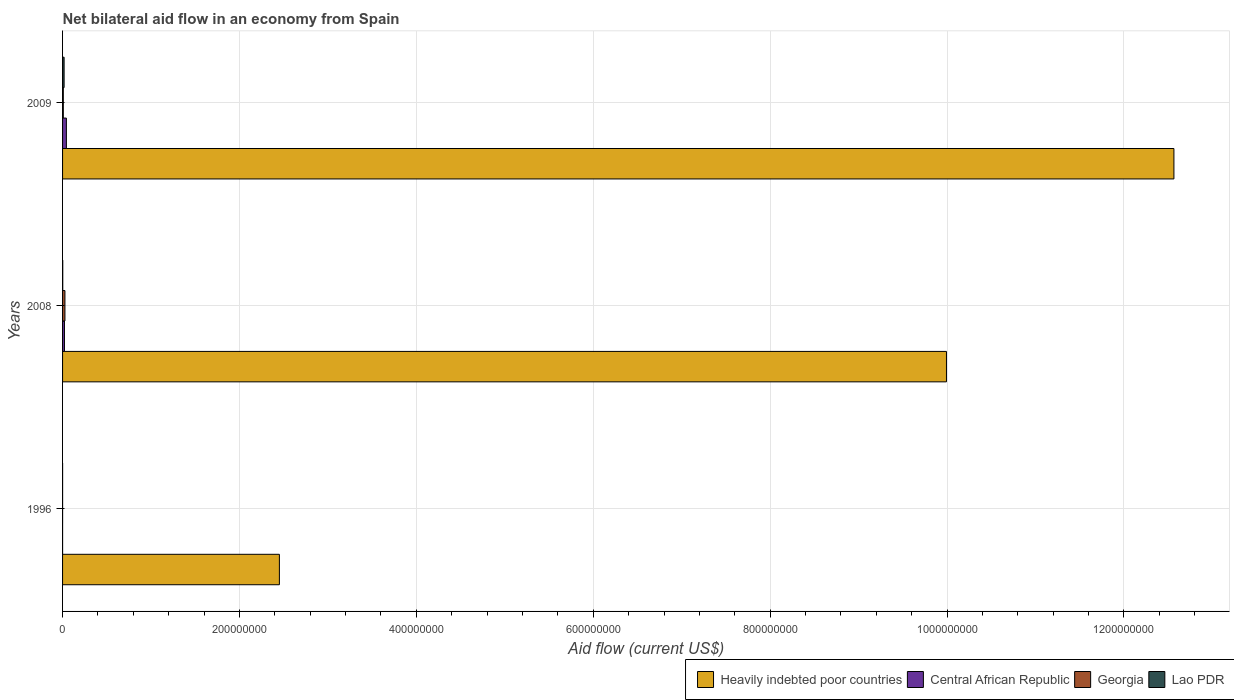Are the number of bars on each tick of the Y-axis equal?
Your answer should be very brief. Yes. How many bars are there on the 3rd tick from the bottom?
Ensure brevity in your answer.  4. What is the net bilateral aid flow in Central African Republic in 2008?
Make the answer very short. 2.15e+06. Across all years, what is the maximum net bilateral aid flow in Georgia?
Give a very brief answer. 2.69e+06. Across all years, what is the minimum net bilateral aid flow in Georgia?
Make the answer very short. 3.00e+04. In which year was the net bilateral aid flow in Central African Republic maximum?
Offer a terse response. 2009. What is the total net bilateral aid flow in Heavily indebted poor countries in the graph?
Make the answer very short. 2.50e+09. What is the difference between the net bilateral aid flow in Lao PDR in 2008 and that in 2009?
Provide a short and direct response. -1.54e+06. What is the difference between the net bilateral aid flow in Central African Republic in 2009 and the net bilateral aid flow in Lao PDR in 2008?
Your answer should be very brief. 4.13e+06. What is the average net bilateral aid flow in Heavily indebted poor countries per year?
Your answer should be compact. 8.34e+08. In the year 2009, what is the difference between the net bilateral aid flow in Central African Republic and net bilateral aid flow in Georgia?
Make the answer very short. 3.48e+06. What is the ratio of the net bilateral aid flow in Central African Republic in 2008 to that in 2009?
Your answer should be compact. 0.5. Is the net bilateral aid flow in Heavily indebted poor countries in 1996 less than that in 2008?
Your answer should be very brief. Yes. What is the difference between the highest and the second highest net bilateral aid flow in Lao PDR?
Offer a terse response. 1.54e+06. What is the difference between the highest and the lowest net bilateral aid flow in Lao PDR?
Your answer should be compact. 1.71e+06. In how many years, is the net bilateral aid flow in Lao PDR greater than the average net bilateral aid flow in Lao PDR taken over all years?
Your answer should be compact. 1. Is the sum of the net bilateral aid flow in Heavily indebted poor countries in 2008 and 2009 greater than the maximum net bilateral aid flow in Georgia across all years?
Provide a short and direct response. Yes. Is it the case that in every year, the sum of the net bilateral aid flow in Central African Republic and net bilateral aid flow in Georgia is greater than the sum of net bilateral aid flow in Heavily indebted poor countries and net bilateral aid flow in Lao PDR?
Your answer should be very brief. No. What does the 1st bar from the top in 2008 represents?
Provide a succinct answer. Lao PDR. What does the 4th bar from the bottom in 1996 represents?
Keep it short and to the point. Lao PDR. Is it the case that in every year, the sum of the net bilateral aid flow in Lao PDR and net bilateral aid flow in Central African Republic is greater than the net bilateral aid flow in Heavily indebted poor countries?
Provide a succinct answer. No. How many years are there in the graph?
Provide a succinct answer. 3. Does the graph contain any zero values?
Keep it short and to the point. No. Where does the legend appear in the graph?
Make the answer very short. Bottom right. What is the title of the graph?
Provide a succinct answer. Net bilateral aid flow in an economy from Spain. Does "Indonesia" appear as one of the legend labels in the graph?
Offer a terse response. No. What is the label or title of the X-axis?
Your answer should be compact. Aid flow (current US$). What is the Aid flow (current US$) of Heavily indebted poor countries in 1996?
Make the answer very short. 2.45e+08. What is the Aid flow (current US$) in Central African Republic in 1996?
Provide a short and direct response. 2.00e+04. What is the Aid flow (current US$) in Georgia in 1996?
Keep it short and to the point. 3.00e+04. What is the Aid flow (current US$) of Lao PDR in 1996?
Offer a terse response. 3.00e+04. What is the Aid flow (current US$) in Heavily indebted poor countries in 2008?
Offer a terse response. 9.99e+08. What is the Aid flow (current US$) in Central African Republic in 2008?
Offer a very short reply. 2.15e+06. What is the Aid flow (current US$) of Georgia in 2008?
Offer a terse response. 2.69e+06. What is the Aid flow (current US$) of Heavily indebted poor countries in 2009?
Provide a short and direct response. 1.26e+09. What is the Aid flow (current US$) in Central African Republic in 2009?
Give a very brief answer. 4.33e+06. What is the Aid flow (current US$) of Georgia in 2009?
Provide a succinct answer. 8.50e+05. What is the Aid flow (current US$) of Lao PDR in 2009?
Keep it short and to the point. 1.74e+06. Across all years, what is the maximum Aid flow (current US$) of Heavily indebted poor countries?
Offer a very short reply. 1.26e+09. Across all years, what is the maximum Aid flow (current US$) of Central African Republic?
Your answer should be compact. 4.33e+06. Across all years, what is the maximum Aid flow (current US$) of Georgia?
Give a very brief answer. 2.69e+06. Across all years, what is the maximum Aid flow (current US$) in Lao PDR?
Offer a terse response. 1.74e+06. Across all years, what is the minimum Aid flow (current US$) in Heavily indebted poor countries?
Ensure brevity in your answer.  2.45e+08. Across all years, what is the minimum Aid flow (current US$) in Central African Republic?
Your answer should be compact. 2.00e+04. Across all years, what is the minimum Aid flow (current US$) of Georgia?
Provide a succinct answer. 3.00e+04. Across all years, what is the minimum Aid flow (current US$) in Lao PDR?
Give a very brief answer. 3.00e+04. What is the total Aid flow (current US$) in Heavily indebted poor countries in the graph?
Give a very brief answer. 2.50e+09. What is the total Aid flow (current US$) of Central African Republic in the graph?
Your answer should be very brief. 6.50e+06. What is the total Aid flow (current US$) in Georgia in the graph?
Provide a succinct answer. 3.57e+06. What is the total Aid flow (current US$) of Lao PDR in the graph?
Your response must be concise. 1.97e+06. What is the difference between the Aid flow (current US$) in Heavily indebted poor countries in 1996 and that in 2008?
Your answer should be compact. -7.54e+08. What is the difference between the Aid flow (current US$) in Central African Republic in 1996 and that in 2008?
Make the answer very short. -2.13e+06. What is the difference between the Aid flow (current US$) in Georgia in 1996 and that in 2008?
Provide a succinct answer. -2.66e+06. What is the difference between the Aid flow (current US$) of Heavily indebted poor countries in 1996 and that in 2009?
Your answer should be very brief. -1.01e+09. What is the difference between the Aid flow (current US$) of Central African Republic in 1996 and that in 2009?
Provide a short and direct response. -4.31e+06. What is the difference between the Aid flow (current US$) of Georgia in 1996 and that in 2009?
Keep it short and to the point. -8.20e+05. What is the difference between the Aid flow (current US$) in Lao PDR in 1996 and that in 2009?
Ensure brevity in your answer.  -1.71e+06. What is the difference between the Aid flow (current US$) of Heavily indebted poor countries in 2008 and that in 2009?
Offer a terse response. -2.57e+08. What is the difference between the Aid flow (current US$) of Central African Republic in 2008 and that in 2009?
Ensure brevity in your answer.  -2.18e+06. What is the difference between the Aid flow (current US$) in Georgia in 2008 and that in 2009?
Ensure brevity in your answer.  1.84e+06. What is the difference between the Aid flow (current US$) in Lao PDR in 2008 and that in 2009?
Offer a terse response. -1.54e+06. What is the difference between the Aid flow (current US$) in Heavily indebted poor countries in 1996 and the Aid flow (current US$) in Central African Republic in 2008?
Keep it short and to the point. 2.43e+08. What is the difference between the Aid flow (current US$) of Heavily indebted poor countries in 1996 and the Aid flow (current US$) of Georgia in 2008?
Keep it short and to the point. 2.42e+08. What is the difference between the Aid flow (current US$) of Heavily indebted poor countries in 1996 and the Aid flow (current US$) of Lao PDR in 2008?
Offer a very short reply. 2.45e+08. What is the difference between the Aid flow (current US$) in Central African Republic in 1996 and the Aid flow (current US$) in Georgia in 2008?
Your response must be concise. -2.67e+06. What is the difference between the Aid flow (current US$) of Georgia in 1996 and the Aid flow (current US$) of Lao PDR in 2008?
Give a very brief answer. -1.70e+05. What is the difference between the Aid flow (current US$) in Heavily indebted poor countries in 1996 and the Aid flow (current US$) in Central African Republic in 2009?
Offer a very short reply. 2.41e+08. What is the difference between the Aid flow (current US$) in Heavily indebted poor countries in 1996 and the Aid flow (current US$) in Georgia in 2009?
Give a very brief answer. 2.44e+08. What is the difference between the Aid flow (current US$) of Heavily indebted poor countries in 1996 and the Aid flow (current US$) of Lao PDR in 2009?
Make the answer very short. 2.43e+08. What is the difference between the Aid flow (current US$) in Central African Republic in 1996 and the Aid flow (current US$) in Georgia in 2009?
Ensure brevity in your answer.  -8.30e+05. What is the difference between the Aid flow (current US$) in Central African Republic in 1996 and the Aid flow (current US$) in Lao PDR in 2009?
Your answer should be compact. -1.72e+06. What is the difference between the Aid flow (current US$) in Georgia in 1996 and the Aid flow (current US$) in Lao PDR in 2009?
Your response must be concise. -1.71e+06. What is the difference between the Aid flow (current US$) of Heavily indebted poor countries in 2008 and the Aid flow (current US$) of Central African Republic in 2009?
Your response must be concise. 9.95e+08. What is the difference between the Aid flow (current US$) in Heavily indebted poor countries in 2008 and the Aid flow (current US$) in Georgia in 2009?
Make the answer very short. 9.99e+08. What is the difference between the Aid flow (current US$) of Heavily indebted poor countries in 2008 and the Aid flow (current US$) of Lao PDR in 2009?
Your answer should be very brief. 9.98e+08. What is the difference between the Aid flow (current US$) of Central African Republic in 2008 and the Aid flow (current US$) of Georgia in 2009?
Provide a succinct answer. 1.30e+06. What is the difference between the Aid flow (current US$) in Georgia in 2008 and the Aid flow (current US$) in Lao PDR in 2009?
Your answer should be compact. 9.50e+05. What is the average Aid flow (current US$) of Heavily indebted poor countries per year?
Offer a very short reply. 8.34e+08. What is the average Aid flow (current US$) of Central African Republic per year?
Provide a short and direct response. 2.17e+06. What is the average Aid flow (current US$) of Georgia per year?
Your answer should be compact. 1.19e+06. What is the average Aid flow (current US$) in Lao PDR per year?
Give a very brief answer. 6.57e+05. In the year 1996, what is the difference between the Aid flow (current US$) of Heavily indebted poor countries and Aid flow (current US$) of Central African Republic?
Ensure brevity in your answer.  2.45e+08. In the year 1996, what is the difference between the Aid flow (current US$) in Heavily indebted poor countries and Aid flow (current US$) in Georgia?
Ensure brevity in your answer.  2.45e+08. In the year 1996, what is the difference between the Aid flow (current US$) in Heavily indebted poor countries and Aid flow (current US$) in Lao PDR?
Make the answer very short. 2.45e+08. In the year 1996, what is the difference between the Aid flow (current US$) in Central African Republic and Aid flow (current US$) in Georgia?
Provide a short and direct response. -10000. In the year 2008, what is the difference between the Aid flow (current US$) of Heavily indebted poor countries and Aid flow (current US$) of Central African Republic?
Your answer should be very brief. 9.97e+08. In the year 2008, what is the difference between the Aid flow (current US$) of Heavily indebted poor countries and Aid flow (current US$) of Georgia?
Your answer should be compact. 9.97e+08. In the year 2008, what is the difference between the Aid flow (current US$) in Heavily indebted poor countries and Aid flow (current US$) in Lao PDR?
Offer a very short reply. 9.99e+08. In the year 2008, what is the difference between the Aid flow (current US$) of Central African Republic and Aid flow (current US$) of Georgia?
Provide a succinct answer. -5.40e+05. In the year 2008, what is the difference between the Aid flow (current US$) of Central African Republic and Aid flow (current US$) of Lao PDR?
Ensure brevity in your answer.  1.95e+06. In the year 2008, what is the difference between the Aid flow (current US$) of Georgia and Aid flow (current US$) of Lao PDR?
Offer a very short reply. 2.49e+06. In the year 2009, what is the difference between the Aid flow (current US$) in Heavily indebted poor countries and Aid flow (current US$) in Central African Republic?
Keep it short and to the point. 1.25e+09. In the year 2009, what is the difference between the Aid flow (current US$) in Heavily indebted poor countries and Aid flow (current US$) in Georgia?
Offer a very short reply. 1.26e+09. In the year 2009, what is the difference between the Aid flow (current US$) of Heavily indebted poor countries and Aid flow (current US$) of Lao PDR?
Your answer should be very brief. 1.25e+09. In the year 2009, what is the difference between the Aid flow (current US$) in Central African Republic and Aid flow (current US$) in Georgia?
Provide a short and direct response. 3.48e+06. In the year 2009, what is the difference between the Aid flow (current US$) in Central African Republic and Aid flow (current US$) in Lao PDR?
Give a very brief answer. 2.59e+06. In the year 2009, what is the difference between the Aid flow (current US$) of Georgia and Aid flow (current US$) of Lao PDR?
Give a very brief answer. -8.90e+05. What is the ratio of the Aid flow (current US$) in Heavily indebted poor countries in 1996 to that in 2008?
Your answer should be very brief. 0.25. What is the ratio of the Aid flow (current US$) in Central African Republic in 1996 to that in 2008?
Ensure brevity in your answer.  0.01. What is the ratio of the Aid flow (current US$) of Georgia in 1996 to that in 2008?
Your response must be concise. 0.01. What is the ratio of the Aid flow (current US$) in Heavily indebted poor countries in 1996 to that in 2009?
Offer a very short reply. 0.2. What is the ratio of the Aid flow (current US$) of Central African Republic in 1996 to that in 2009?
Provide a succinct answer. 0. What is the ratio of the Aid flow (current US$) of Georgia in 1996 to that in 2009?
Offer a terse response. 0.04. What is the ratio of the Aid flow (current US$) in Lao PDR in 1996 to that in 2009?
Provide a short and direct response. 0.02. What is the ratio of the Aid flow (current US$) in Heavily indebted poor countries in 2008 to that in 2009?
Your response must be concise. 0.8. What is the ratio of the Aid flow (current US$) of Central African Republic in 2008 to that in 2009?
Your answer should be compact. 0.5. What is the ratio of the Aid flow (current US$) in Georgia in 2008 to that in 2009?
Ensure brevity in your answer.  3.16. What is the ratio of the Aid flow (current US$) in Lao PDR in 2008 to that in 2009?
Give a very brief answer. 0.11. What is the difference between the highest and the second highest Aid flow (current US$) of Heavily indebted poor countries?
Your answer should be compact. 2.57e+08. What is the difference between the highest and the second highest Aid flow (current US$) of Central African Republic?
Provide a short and direct response. 2.18e+06. What is the difference between the highest and the second highest Aid flow (current US$) in Georgia?
Offer a terse response. 1.84e+06. What is the difference between the highest and the second highest Aid flow (current US$) in Lao PDR?
Ensure brevity in your answer.  1.54e+06. What is the difference between the highest and the lowest Aid flow (current US$) in Heavily indebted poor countries?
Make the answer very short. 1.01e+09. What is the difference between the highest and the lowest Aid flow (current US$) in Central African Republic?
Your answer should be compact. 4.31e+06. What is the difference between the highest and the lowest Aid flow (current US$) of Georgia?
Your response must be concise. 2.66e+06. What is the difference between the highest and the lowest Aid flow (current US$) in Lao PDR?
Offer a terse response. 1.71e+06. 